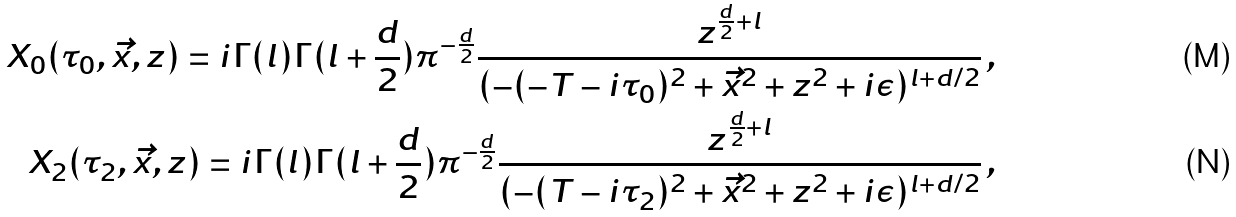<formula> <loc_0><loc_0><loc_500><loc_500>X _ { 0 } ( \tau _ { 0 } , \vec { x } , z ) = i \Gamma ( l ) \Gamma ( l + \frac { d } { 2 } ) \pi ^ { - \frac { d } { 2 } } \frac { z ^ { \frac { d } { 2 } + l } } { ( - ( - T - i \tau _ { 0 } ) ^ { 2 } + \vec { x } ^ { 2 } + z ^ { 2 } + i \epsilon ) ^ { l + d / 2 } } \, , \\ X _ { 2 } ( \tau _ { 2 } , \vec { x } , z ) = i \Gamma ( l ) \Gamma ( l + \frac { d } { 2 } ) \pi ^ { - \frac { d } { 2 } } \frac { z ^ { \frac { d } { 2 } + l } } { ( - ( T - i \tau _ { 2 } ) ^ { 2 } + \vec { x } ^ { 2 } + z ^ { 2 } + i \epsilon ) ^ { l + d / 2 } } \, ,</formula> 